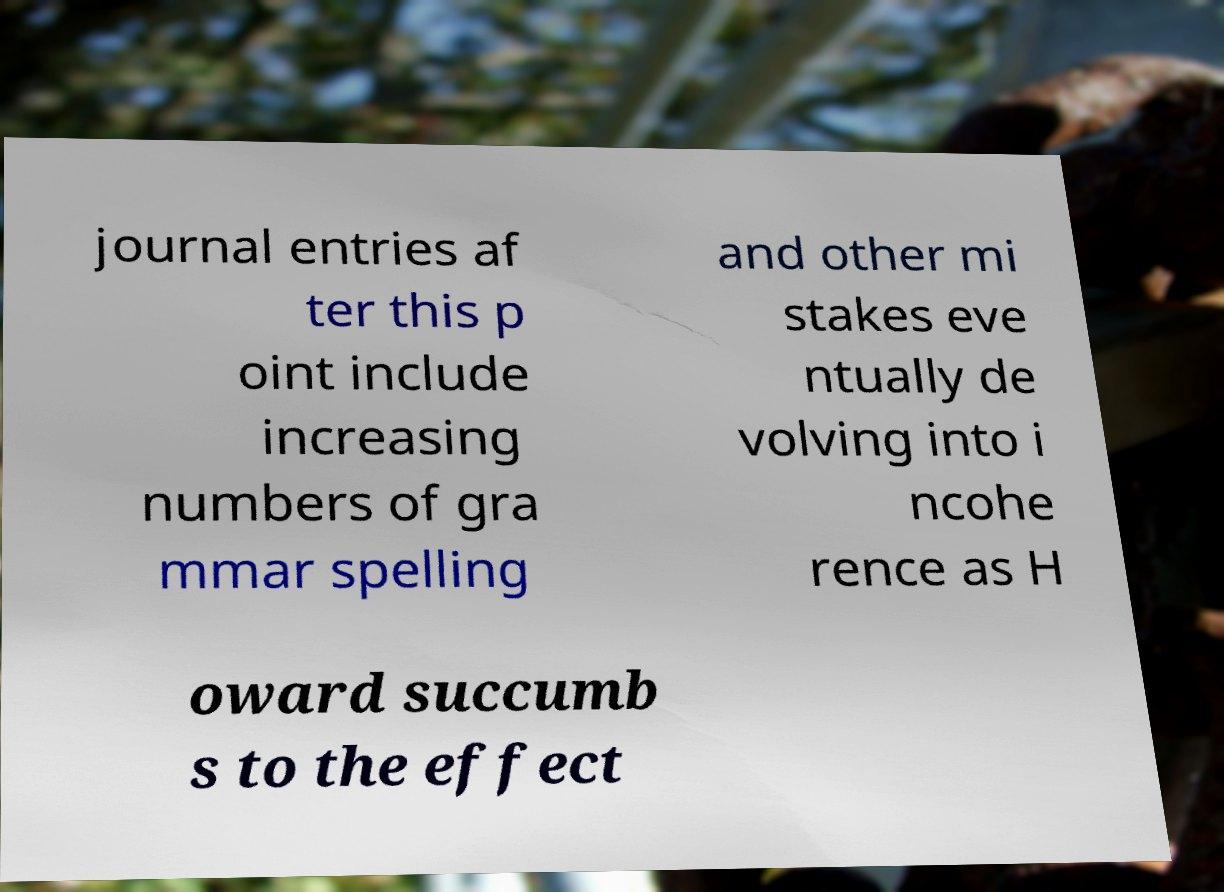For documentation purposes, I need the text within this image transcribed. Could you provide that? journal entries af ter this p oint include increasing numbers of gra mmar spelling and other mi stakes eve ntually de volving into i ncohe rence as H oward succumb s to the effect 